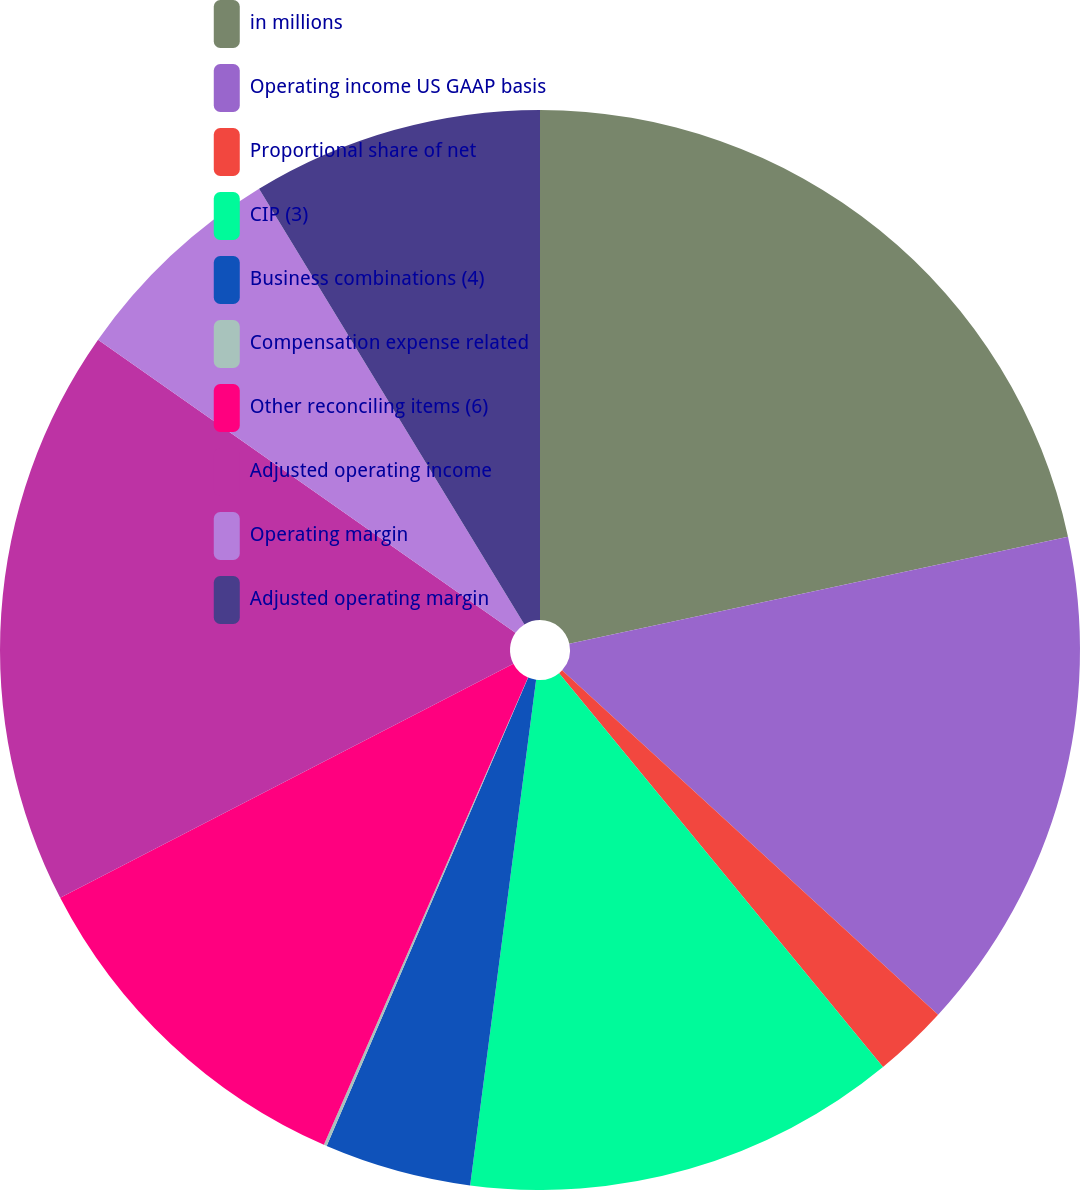Convert chart to OTSL. <chart><loc_0><loc_0><loc_500><loc_500><pie_chart><fcel>in millions<fcel>Operating income US GAAP basis<fcel>Proportional share of net<fcel>CIP (3)<fcel>Business combinations (4)<fcel>Compensation expense related<fcel>Other reconciling items (6)<fcel>Adjusted operating income<fcel>Operating margin<fcel>Adjusted operating margin<nl><fcel>21.64%<fcel>15.17%<fcel>2.24%<fcel>13.02%<fcel>4.4%<fcel>0.09%<fcel>10.86%<fcel>17.33%<fcel>6.55%<fcel>8.71%<nl></chart> 